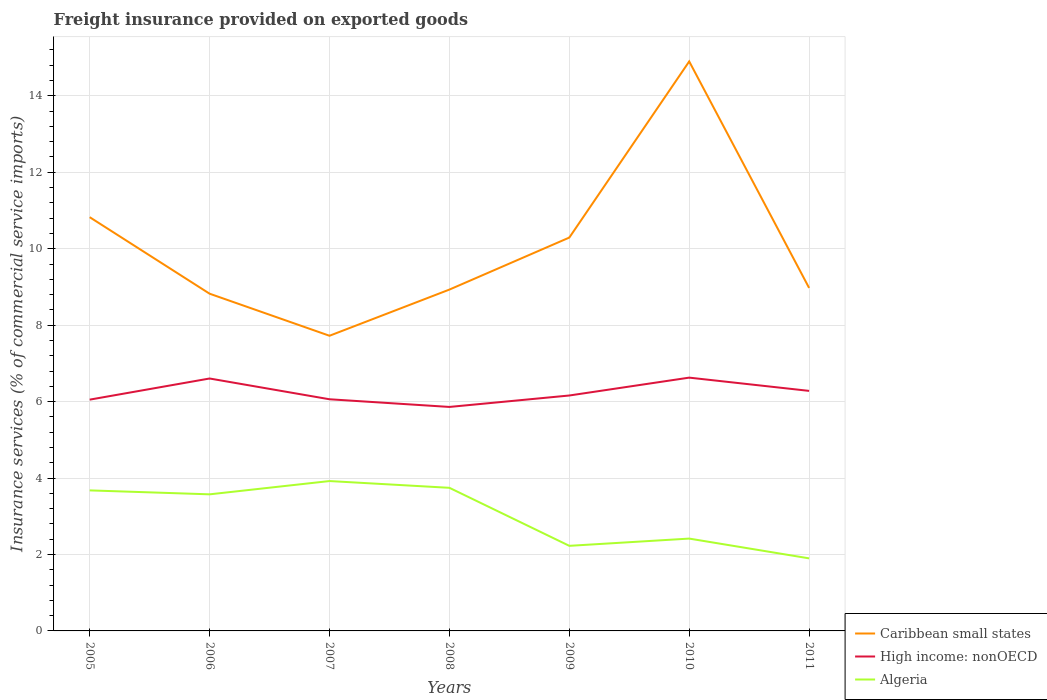How many different coloured lines are there?
Your answer should be very brief. 3. Is the number of lines equal to the number of legend labels?
Your response must be concise. Yes. Across all years, what is the maximum freight insurance provided on exported goods in Caribbean small states?
Provide a short and direct response. 7.72. What is the total freight insurance provided on exported goods in Caribbean small states in the graph?
Your answer should be very brief. -1.47. What is the difference between the highest and the second highest freight insurance provided on exported goods in High income: nonOECD?
Offer a very short reply. 0.77. How many lines are there?
Provide a succinct answer. 3. How many years are there in the graph?
Offer a terse response. 7. Are the values on the major ticks of Y-axis written in scientific E-notation?
Offer a very short reply. No. Does the graph contain grids?
Keep it short and to the point. Yes. How many legend labels are there?
Your answer should be compact. 3. What is the title of the graph?
Provide a short and direct response. Freight insurance provided on exported goods. What is the label or title of the X-axis?
Keep it short and to the point. Years. What is the label or title of the Y-axis?
Give a very brief answer. Insurance services (% of commercial service imports). What is the Insurance services (% of commercial service imports) in Caribbean small states in 2005?
Your answer should be compact. 10.83. What is the Insurance services (% of commercial service imports) of High income: nonOECD in 2005?
Keep it short and to the point. 6.05. What is the Insurance services (% of commercial service imports) in Algeria in 2005?
Keep it short and to the point. 3.68. What is the Insurance services (% of commercial service imports) of Caribbean small states in 2006?
Keep it short and to the point. 8.82. What is the Insurance services (% of commercial service imports) of High income: nonOECD in 2006?
Provide a succinct answer. 6.6. What is the Insurance services (% of commercial service imports) of Algeria in 2006?
Make the answer very short. 3.57. What is the Insurance services (% of commercial service imports) in Caribbean small states in 2007?
Your answer should be very brief. 7.72. What is the Insurance services (% of commercial service imports) of High income: nonOECD in 2007?
Ensure brevity in your answer.  6.06. What is the Insurance services (% of commercial service imports) of Algeria in 2007?
Keep it short and to the point. 3.92. What is the Insurance services (% of commercial service imports) of Caribbean small states in 2008?
Keep it short and to the point. 8.93. What is the Insurance services (% of commercial service imports) of High income: nonOECD in 2008?
Give a very brief answer. 5.86. What is the Insurance services (% of commercial service imports) of Algeria in 2008?
Give a very brief answer. 3.74. What is the Insurance services (% of commercial service imports) in Caribbean small states in 2009?
Provide a succinct answer. 10.29. What is the Insurance services (% of commercial service imports) of High income: nonOECD in 2009?
Provide a succinct answer. 6.16. What is the Insurance services (% of commercial service imports) of Algeria in 2009?
Make the answer very short. 2.23. What is the Insurance services (% of commercial service imports) in Caribbean small states in 2010?
Provide a succinct answer. 14.9. What is the Insurance services (% of commercial service imports) of High income: nonOECD in 2010?
Provide a succinct answer. 6.63. What is the Insurance services (% of commercial service imports) in Algeria in 2010?
Provide a succinct answer. 2.42. What is the Insurance services (% of commercial service imports) in Caribbean small states in 2011?
Your response must be concise. 8.97. What is the Insurance services (% of commercial service imports) in High income: nonOECD in 2011?
Provide a succinct answer. 6.28. What is the Insurance services (% of commercial service imports) of Algeria in 2011?
Offer a terse response. 1.9. Across all years, what is the maximum Insurance services (% of commercial service imports) of Caribbean small states?
Make the answer very short. 14.9. Across all years, what is the maximum Insurance services (% of commercial service imports) in High income: nonOECD?
Offer a terse response. 6.63. Across all years, what is the maximum Insurance services (% of commercial service imports) of Algeria?
Your answer should be very brief. 3.92. Across all years, what is the minimum Insurance services (% of commercial service imports) in Caribbean small states?
Ensure brevity in your answer.  7.72. Across all years, what is the minimum Insurance services (% of commercial service imports) of High income: nonOECD?
Offer a very short reply. 5.86. Across all years, what is the minimum Insurance services (% of commercial service imports) in Algeria?
Give a very brief answer. 1.9. What is the total Insurance services (% of commercial service imports) in Caribbean small states in the graph?
Provide a succinct answer. 70.47. What is the total Insurance services (% of commercial service imports) in High income: nonOECD in the graph?
Make the answer very short. 43.64. What is the total Insurance services (% of commercial service imports) of Algeria in the graph?
Offer a very short reply. 21.46. What is the difference between the Insurance services (% of commercial service imports) of Caribbean small states in 2005 and that in 2006?
Provide a succinct answer. 2. What is the difference between the Insurance services (% of commercial service imports) in High income: nonOECD in 2005 and that in 2006?
Offer a very short reply. -0.55. What is the difference between the Insurance services (% of commercial service imports) of Algeria in 2005 and that in 2006?
Offer a terse response. 0.1. What is the difference between the Insurance services (% of commercial service imports) in Caribbean small states in 2005 and that in 2007?
Keep it short and to the point. 3.1. What is the difference between the Insurance services (% of commercial service imports) in High income: nonOECD in 2005 and that in 2007?
Your response must be concise. -0.01. What is the difference between the Insurance services (% of commercial service imports) in Algeria in 2005 and that in 2007?
Provide a short and direct response. -0.24. What is the difference between the Insurance services (% of commercial service imports) of Caribbean small states in 2005 and that in 2008?
Ensure brevity in your answer.  1.89. What is the difference between the Insurance services (% of commercial service imports) of High income: nonOECD in 2005 and that in 2008?
Offer a very short reply. 0.19. What is the difference between the Insurance services (% of commercial service imports) of Algeria in 2005 and that in 2008?
Your response must be concise. -0.07. What is the difference between the Insurance services (% of commercial service imports) in Caribbean small states in 2005 and that in 2009?
Your answer should be very brief. 0.53. What is the difference between the Insurance services (% of commercial service imports) of High income: nonOECD in 2005 and that in 2009?
Your answer should be compact. -0.11. What is the difference between the Insurance services (% of commercial service imports) in Algeria in 2005 and that in 2009?
Offer a very short reply. 1.45. What is the difference between the Insurance services (% of commercial service imports) of Caribbean small states in 2005 and that in 2010?
Provide a short and direct response. -4.08. What is the difference between the Insurance services (% of commercial service imports) in High income: nonOECD in 2005 and that in 2010?
Provide a succinct answer. -0.58. What is the difference between the Insurance services (% of commercial service imports) in Algeria in 2005 and that in 2010?
Keep it short and to the point. 1.26. What is the difference between the Insurance services (% of commercial service imports) of Caribbean small states in 2005 and that in 2011?
Your answer should be very brief. 1.85. What is the difference between the Insurance services (% of commercial service imports) of High income: nonOECD in 2005 and that in 2011?
Your response must be concise. -0.23. What is the difference between the Insurance services (% of commercial service imports) of Algeria in 2005 and that in 2011?
Your answer should be compact. 1.78. What is the difference between the Insurance services (% of commercial service imports) in Caribbean small states in 2006 and that in 2007?
Ensure brevity in your answer.  1.1. What is the difference between the Insurance services (% of commercial service imports) of High income: nonOECD in 2006 and that in 2007?
Provide a succinct answer. 0.54. What is the difference between the Insurance services (% of commercial service imports) in Algeria in 2006 and that in 2007?
Provide a short and direct response. -0.35. What is the difference between the Insurance services (% of commercial service imports) in Caribbean small states in 2006 and that in 2008?
Your answer should be compact. -0.11. What is the difference between the Insurance services (% of commercial service imports) in High income: nonOECD in 2006 and that in 2008?
Keep it short and to the point. 0.74. What is the difference between the Insurance services (% of commercial service imports) of Algeria in 2006 and that in 2008?
Give a very brief answer. -0.17. What is the difference between the Insurance services (% of commercial service imports) in Caribbean small states in 2006 and that in 2009?
Offer a terse response. -1.47. What is the difference between the Insurance services (% of commercial service imports) of High income: nonOECD in 2006 and that in 2009?
Make the answer very short. 0.45. What is the difference between the Insurance services (% of commercial service imports) in Algeria in 2006 and that in 2009?
Provide a short and direct response. 1.35. What is the difference between the Insurance services (% of commercial service imports) in Caribbean small states in 2006 and that in 2010?
Offer a terse response. -6.08. What is the difference between the Insurance services (% of commercial service imports) of High income: nonOECD in 2006 and that in 2010?
Offer a very short reply. -0.02. What is the difference between the Insurance services (% of commercial service imports) of Algeria in 2006 and that in 2010?
Your answer should be very brief. 1.16. What is the difference between the Insurance services (% of commercial service imports) in Caribbean small states in 2006 and that in 2011?
Offer a terse response. -0.15. What is the difference between the Insurance services (% of commercial service imports) of High income: nonOECD in 2006 and that in 2011?
Your answer should be very brief. 0.32. What is the difference between the Insurance services (% of commercial service imports) of Algeria in 2006 and that in 2011?
Make the answer very short. 1.68. What is the difference between the Insurance services (% of commercial service imports) of Caribbean small states in 2007 and that in 2008?
Provide a short and direct response. -1.21. What is the difference between the Insurance services (% of commercial service imports) of High income: nonOECD in 2007 and that in 2008?
Give a very brief answer. 0.2. What is the difference between the Insurance services (% of commercial service imports) in Algeria in 2007 and that in 2008?
Offer a very short reply. 0.18. What is the difference between the Insurance services (% of commercial service imports) in Caribbean small states in 2007 and that in 2009?
Your response must be concise. -2.57. What is the difference between the Insurance services (% of commercial service imports) of High income: nonOECD in 2007 and that in 2009?
Offer a very short reply. -0.1. What is the difference between the Insurance services (% of commercial service imports) of Algeria in 2007 and that in 2009?
Provide a succinct answer. 1.69. What is the difference between the Insurance services (% of commercial service imports) in Caribbean small states in 2007 and that in 2010?
Provide a succinct answer. -7.18. What is the difference between the Insurance services (% of commercial service imports) in High income: nonOECD in 2007 and that in 2010?
Provide a short and direct response. -0.57. What is the difference between the Insurance services (% of commercial service imports) of Algeria in 2007 and that in 2010?
Ensure brevity in your answer.  1.51. What is the difference between the Insurance services (% of commercial service imports) in Caribbean small states in 2007 and that in 2011?
Your answer should be very brief. -1.25. What is the difference between the Insurance services (% of commercial service imports) in High income: nonOECD in 2007 and that in 2011?
Offer a terse response. -0.22. What is the difference between the Insurance services (% of commercial service imports) of Algeria in 2007 and that in 2011?
Keep it short and to the point. 2.02. What is the difference between the Insurance services (% of commercial service imports) of Caribbean small states in 2008 and that in 2009?
Give a very brief answer. -1.36. What is the difference between the Insurance services (% of commercial service imports) in High income: nonOECD in 2008 and that in 2009?
Your answer should be compact. -0.3. What is the difference between the Insurance services (% of commercial service imports) in Algeria in 2008 and that in 2009?
Provide a succinct answer. 1.52. What is the difference between the Insurance services (% of commercial service imports) of Caribbean small states in 2008 and that in 2010?
Give a very brief answer. -5.97. What is the difference between the Insurance services (% of commercial service imports) of High income: nonOECD in 2008 and that in 2010?
Offer a very short reply. -0.77. What is the difference between the Insurance services (% of commercial service imports) in Algeria in 2008 and that in 2010?
Offer a very short reply. 1.33. What is the difference between the Insurance services (% of commercial service imports) of Caribbean small states in 2008 and that in 2011?
Offer a very short reply. -0.04. What is the difference between the Insurance services (% of commercial service imports) of High income: nonOECD in 2008 and that in 2011?
Your answer should be very brief. -0.42. What is the difference between the Insurance services (% of commercial service imports) in Algeria in 2008 and that in 2011?
Your answer should be very brief. 1.85. What is the difference between the Insurance services (% of commercial service imports) of Caribbean small states in 2009 and that in 2010?
Keep it short and to the point. -4.61. What is the difference between the Insurance services (% of commercial service imports) in High income: nonOECD in 2009 and that in 2010?
Keep it short and to the point. -0.47. What is the difference between the Insurance services (% of commercial service imports) of Algeria in 2009 and that in 2010?
Make the answer very short. -0.19. What is the difference between the Insurance services (% of commercial service imports) of Caribbean small states in 2009 and that in 2011?
Your answer should be very brief. 1.32. What is the difference between the Insurance services (% of commercial service imports) in High income: nonOECD in 2009 and that in 2011?
Offer a terse response. -0.12. What is the difference between the Insurance services (% of commercial service imports) of Algeria in 2009 and that in 2011?
Ensure brevity in your answer.  0.33. What is the difference between the Insurance services (% of commercial service imports) of Caribbean small states in 2010 and that in 2011?
Give a very brief answer. 5.93. What is the difference between the Insurance services (% of commercial service imports) of High income: nonOECD in 2010 and that in 2011?
Provide a succinct answer. 0.35. What is the difference between the Insurance services (% of commercial service imports) of Algeria in 2010 and that in 2011?
Keep it short and to the point. 0.52. What is the difference between the Insurance services (% of commercial service imports) in Caribbean small states in 2005 and the Insurance services (% of commercial service imports) in High income: nonOECD in 2006?
Make the answer very short. 4.22. What is the difference between the Insurance services (% of commercial service imports) in Caribbean small states in 2005 and the Insurance services (% of commercial service imports) in Algeria in 2006?
Offer a terse response. 7.25. What is the difference between the Insurance services (% of commercial service imports) of High income: nonOECD in 2005 and the Insurance services (% of commercial service imports) of Algeria in 2006?
Provide a succinct answer. 2.48. What is the difference between the Insurance services (% of commercial service imports) of Caribbean small states in 2005 and the Insurance services (% of commercial service imports) of High income: nonOECD in 2007?
Provide a short and direct response. 4.76. What is the difference between the Insurance services (% of commercial service imports) in Caribbean small states in 2005 and the Insurance services (% of commercial service imports) in Algeria in 2007?
Keep it short and to the point. 6.9. What is the difference between the Insurance services (% of commercial service imports) in High income: nonOECD in 2005 and the Insurance services (% of commercial service imports) in Algeria in 2007?
Your answer should be compact. 2.13. What is the difference between the Insurance services (% of commercial service imports) of Caribbean small states in 2005 and the Insurance services (% of commercial service imports) of High income: nonOECD in 2008?
Ensure brevity in your answer.  4.97. What is the difference between the Insurance services (% of commercial service imports) of Caribbean small states in 2005 and the Insurance services (% of commercial service imports) of Algeria in 2008?
Provide a succinct answer. 7.08. What is the difference between the Insurance services (% of commercial service imports) of High income: nonOECD in 2005 and the Insurance services (% of commercial service imports) of Algeria in 2008?
Offer a very short reply. 2.31. What is the difference between the Insurance services (% of commercial service imports) of Caribbean small states in 2005 and the Insurance services (% of commercial service imports) of High income: nonOECD in 2009?
Ensure brevity in your answer.  4.67. What is the difference between the Insurance services (% of commercial service imports) in Caribbean small states in 2005 and the Insurance services (% of commercial service imports) in Algeria in 2009?
Keep it short and to the point. 8.6. What is the difference between the Insurance services (% of commercial service imports) in High income: nonOECD in 2005 and the Insurance services (% of commercial service imports) in Algeria in 2009?
Your response must be concise. 3.83. What is the difference between the Insurance services (% of commercial service imports) in Caribbean small states in 2005 and the Insurance services (% of commercial service imports) in High income: nonOECD in 2010?
Keep it short and to the point. 4.2. What is the difference between the Insurance services (% of commercial service imports) of Caribbean small states in 2005 and the Insurance services (% of commercial service imports) of Algeria in 2010?
Your answer should be compact. 8.41. What is the difference between the Insurance services (% of commercial service imports) of High income: nonOECD in 2005 and the Insurance services (% of commercial service imports) of Algeria in 2010?
Offer a terse response. 3.64. What is the difference between the Insurance services (% of commercial service imports) in Caribbean small states in 2005 and the Insurance services (% of commercial service imports) in High income: nonOECD in 2011?
Provide a short and direct response. 4.54. What is the difference between the Insurance services (% of commercial service imports) of Caribbean small states in 2005 and the Insurance services (% of commercial service imports) of Algeria in 2011?
Keep it short and to the point. 8.93. What is the difference between the Insurance services (% of commercial service imports) in High income: nonOECD in 2005 and the Insurance services (% of commercial service imports) in Algeria in 2011?
Offer a terse response. 4.15. What is the difference between the Insurance services (% of commercial service imports) of Caribbean small states in 2006 and the Insurance services (% of commercial service imports) of High income: nonOECD in 2007?
Provide a short and direct response. 2.76. What is the difference between the Insurance services (% of commercial service imports) in Caribbean small states in 2006 and the Insurance services (% of commercial service imports) in Algeria in 2007?
Keep it short and to the point. 4.9. What is the difference between the Insurance services (% of commercial service imports) in High income: nonOECD in 2006 and the Insurance services (% of commercial service imports) in Algeria in 2007?
Make the answer very short. 2.68. What is the difference between the Insurance services (% of commercial service imports) of Caribbean small states in 2006 and the Insurance services (% of commercial service imports) of High income: nonOECD in 2008?
Your response must be concise. 2.96. What is the difference between the Insurance services (% of commercial service imports) in Caribbean small states in 2006 and the Insurance services (% of commercial service imports) in Algeria in 2008?
Offer a terse response. 5.08. What is the difference between the Insurance services (% of commercial service imports) in High income: nonOECD in 2006 and the Insurance services (% of commercial service imports) in Algeria in 2008?
Your answer should be compact. 2.86. What is the difference between the Insurance services (% of commercial service imports) in Caribbean small states in 2006 and the Insurance services (% of commercial service imports) in High income: nonOECD in 2009?
Your response must be concise. 2.66. What is the difference between the Insurance services (% of commercial service imports) in Caribbean small states in 2006 and the Insurance services (% of commercial service imports) in Algeria in 2009?
Offer a very short reply. 6.6. What is the difference between the Insurance services (% of commercial service imports) of High income: nonOECD in 2006 and the Insurance services (% of commercial service imports) of Algeria in 2009?
Give a very brief answer. 4.38. What is the difference between the Insurance services (% of commercial service imports) of Caribbean small states in 2006 and the Insurance services (% of commercial service imports) of High income: nonOECD in 2010?
Give a very brief answer. 2.2. What is the difference between the Insurance services (% of commercial service imports) in Caribbean small states in 2006 and the Insurance services (% of commercial service imports) in Algeria in 2010?
Ensure brevity in your answer.  6.41. What is the difference between the Insurance services (% of commercial service imports) in High income: nonOECD in 2006 and the Insurance services (% of commercial service imports) in Algeria in 2010?
Offer a terse response. 4.19. What is the difference between the Insurance services (% of commercial service imports) of Caribbean small states in 2006 and the Insurance services (% of commercial service imports) of High income: nonOECD in 2011?
Give a very brief answer. 2.54. What is the difference between the Insurance services (% of commercial service imports) of Caribbean small states in 2006 and the Insurance services (% of commercial service imports) of Algeria in 2011?
Keep it short and to the point. 6.92. What is the difference between the Insurance services (% of commercial service imports) in High income: nonOECD in 2006 and the Insurance services (% of commercial service imports) in Algeria in 2011?
Provide a succinct answer. 4.71. What is the difference between the Insurance services (% of commercial service imports) of Caribbean small states in 2007 and the Insurance services (% of commercial service imports) of High income: nonOECD in 2008?
Your response must be concise. 1.86. What is the difference between the Insurance services (% of commercial service imports) of Caribbean small states in 2007 and the Insurance services (% of commercial service imports) of Algeria in 2008?
Provide a succinct answer. 3.98. What is the difference between the Insurance services (% of commercial service imports) in High income: nonOECD in 2007 and the Insurance services (% of commercial service imports) in Algeria in 2008?
Ensure brevity in your answer.  2.32. What is the difference between the Insurance services (% of commercial service imports) of Caribbean small states in 2007 and the Insurance services (% of commercial service imports) of High income: nonOECD in 2009?
Give a very brief answer. 1.56. What is the difference between the Insurance services (% of commercial service imports) of Caribbean small states in 2007 and the Insurance services (% of commercial service imports) of Algeria in 2009?
Offer a terse response. 5.5. What is the difference between the Insurance services (% of commercial service imports) in High income: nonOECD in 2007 and the Insurance services (% of commercial service imports) in Algeria in 2009?
Your answer should be compact. 3.83. What is the difference between the Insurance services (% of commercial service imports) of Caribbean small states in 2007 and the Insurance services (% of commercial service imports) of High income: nonOECD in 2010?
Give a very brief answer. 1.1. What is the difference between the Insurance services (% of commercial service imports) in Caribbean small states in 2007 and the Insurance services (% of commercial service imports) in Algeria in 2010?
Your answer should be very brief. 5.31. What is the difference between the Insurance services (% of commercial service imports) in High income: nonOECD in 2007 and the Insurance services (% of commercial service imports) in Algeria in 2010?
Keep it short and to the point. 3.65. What is the difference between the Insurance services (% of commercial service imports) in Caribbean small states in 2007 and the Insurance services (% of commercial service imports) in High income: nonOECD in 2011?
Your answer should be very brief. 1.44. What is the difference between the Insurance services (% of commercial service imports) of Caribbean small states in 2007 and the Insurance services (% of commercial service imports) of Algeria in 2011?
Keep it short and to the point. 5.82. What is the difference between the Insurance services (% of commercial service imports) in High income: nonOECD in 2007 and the Insurance services (% of commercial service imports) in Algeria in 2011?
Your response must be concise. 4.16. What is the difference between the Insurance services (% of commercial service imports) in Caribbean small states in 2008 and the Insurance services (% of commercial service imports) in High income: nonOECD in 2009?
Offer a very short reply. 2.77. What is the difference between the Insurance services (% of commercial service imports) of Caribbean small states in 2008 and the Insurance services (% of commercial service imports) of Algeria in 2009?
Your answer should be compact. 6.7. What is the difference between the Insurance services (% of commercial service imports) in High income: nonOECD in 2008 and the Insurance services (% of commercial service imports) in Algeria in 2009?
Offer a terse response. 3.63. What is the difference between the Insurance services (% of commercial service imports) of Caribbean small states in 2008 and the Insurance services (% of commercial service imports) of High income: nonOECD in 2010?
Make the answer very short. 2.3. What is the difference between the Insurance services (% of commercial service imports) of Caribbean small states in 2008 and the Insurance services (% of commercial service imports) of Algeria in 2010?
Ensure brevity in your answer.  6.51. What is the difference between the Insurance services (% of commercial service imports) of High income: nonOECD in 2008 and the Insurance services (% of commercial service imports) of Algeria in 2010?
Your answer should be compact. 3.44. What is the difference between the Insurance services (% of commercial service imports) of Caribbean small states in 2008 and the Insurance services (% of commercial service imports) of High income: nonOECD in 2011?
Your answer should be very brief. 2.65. What is the difference between the Insurance services (% of commercial service imports) in Caribbean small states in 2008 and the Insurance services (% of commercial service imports) in Algeria in 2011?
Your response must be concise. 7.03. What is the difference between the Insurance services (% of commercial service imports) of High income: nonOECD in 2008 and the Insurance services (% of commercial service imports) of Algeria in 2011?
Your answer should be very brief. 3.96. What is the difference between the Insurance services (% of commercial service imports) in Caribbean small states in 2009 and the Insurance services (% of commercial service imports) in High income: nonOECD in 2010?
Provide a short and direct response. 3.66. What is the difference between the Insurance services (% of commercial service imports) in Caribbean small states in 2009 and the Insurance services (% of commercial service imports) in Algeria in 2010?
Offer a terse response. 7.88. What is the difference between the Insurance services (% of commercial service imports) in High income: nonOECD in 2009 and the Insurance services (% of commercial service imports) in Algeria in 2010?
Offer a terse response. 3.74. What is the difference between the Insurance services (% of commercial service imports) of Caribbean small states in 2009 and the Insurance services (% of commercial service imports) of High income: nonOECD in 2011?
Give a very brief answer. 4.01. What is the difference between the Insurance services (% of commercial service imports) in Caribbean small states in 2009 and the Insurance services (% of commercial service imports) in Algeria in 2011?
Offer a terse response. 8.39. What is the difference between the Insurance services (% of commercial service imports) of High income: nonOECD in 2009 and the Insurance services (% of commercial service imports) of Algeria in 2011?
Make the answer very short. 4.26. What is the difference between the Insurance services (% of commercial service imports) of Caribbean small states in 2010 and the Insurance services (% of commercial service imports) of High income: nonOECD in 2011?
Provide a succinct answer. 8.62. What is the difference between the Insurance services (% of commercial service imports) in Caribbean small states in 2010 and the Insurance services (% of commercial service imports) in Algeria in 2011?
Provide a short and direct response. 13. What is the difference between the Insurance services (% of commercial service imports) in High income: nonOECD in 2010 and the Insurance services (% of commercial service imports) in Algeria in 2011?
Offer a very short reply. 4.73. What is the average Insurance services (% of commercial service imports) of Caribbean small states per year?
Make the answer very short. 10.07. What is the average Insurance services (% of commercial service imports) of High income: nonOECD per year?
Your answer should be compact. 6.24. What is the average Insurance services (% of commercial service imports) in Algeria per year?
Offer a terse response. 3.07. In the year 2005, what is the difference between the Insurance services (% of commercial service imports) of Caribbean small states and Insurance services (% of commercial service imports) of High income: nonOECD?
Provide a succinct answer. 4.77. In the year 2005, what is the difference between the Insurance services (% of commercial service imports) in Caribbean small states and Insurance services (% of commercial service imports) in Algeria?
Make the answer very short. 7.15. In the year 2005, what is the difference between the Insurance services (% of commercial service imports) of High income: nonOECD and Insurance services (% of commercial service imports) of Algeria?
Make the answer very short. 2.37. In the year 2006, what is the difference between the Insurance services (% of commercial service imports) of Caribbean small states and Insurance services (% of commercial service imports) of High income: nonOECD?
Offer a terse response. 2.22. In the year 2006, what is the difference between the Insurance services (% of commercial service imports) of Caribbean small states and Insurance services (% of commercial service imports) of Algeria?
Your answer should be very brief. 5.25. In the year 2006, what is the difference between the Insurance services (% of commercial service imports) in High income: nonOECD and Insurance services (% of commercial service imports) in Algeria?
Your response must be concise. 3.03. In the year 2007, what is the difference between the Insurance services (% of commercial service imports) of Caribbean small states and Insurance services (% of commercial service imports) of High income: nonOECD?
Offer a very short reply. 1.66. In the year 2007, what is the difference between the Insurance services (% of commercial service imports) in Caribbean small states and Insurance services (% of commercial service imports) in Algeria?
Provide a succinct answer. 3.8. In the year 2007, what is the difference between the Insurance services (% of commercial service imports) in High income: nonOECD and Insurance services (% of commercial service imports) in Algeria?
Make the answer very short. 2.14. In the year 2008, what is the difference between the Insurance services (% of commercial service imports) of Caribbean small states and Insurance services (% of commercial service imports) of High income: nonOECD?
Your response must be concise. 3.07. In the year 2008, what is the difference between the Insurance services (% of commercial service imports) in Caribbean small states and Insurance services (% of commercial service imports) in Algeria?
Keep it short and to the point. 5.19. In the year 2008, what is the difference between the Insurance services (% of commercial service imports) in High income: nonOECD and Insurance services (% of commercial service imports) in Algeria?
Your answer should be very brief. 2.12. In the year 2009, what is the difference between the Insurance services (% of commercial service imports) of Caribbean small states and Insurance services (% of commercial service imports) of High income: nonOECD?
Offer a very short reply. 4.13. In the year 2009, what is the difference between the Insurance services (% of commercial service imports) of Caribbean small states and Insurance services (% of commercial service imports) of Algeria?
Your response must be concise. 8.07. In the year 2009, what is the difference between the Insurance services (% of commercial service imports) in High income: nonOECD and Insurance services (% of commercial service imports) in Algeria?
Your response must be concise. 3.93. In the year 2010, what is the difference between the Insurance services (% of commercial service imports) in Caribbean small states and Insurance services (% of commercial service imports) in High income: nonOECD?
Your response must be concise. 8.27. In the year 2010, what is the difference between the Insurance services (% of commercial service imports) of Caribbean small states and Insurance services (% of commercial service imports) of Algeria?
Your response must be concise. 12.48. In the year 2010, what is the difference between the Insurance services (% of commercial service imports) of High income: nonOECD and Insurance services (% of commercial service imports) of Algeria?
Offer a terse response. 4.21. In the year 2011, what is the difference between the Insurance services (% of commercial service imports) of Caribbean small states and Insurance services (% of commercial service imports) of High income: nonOECD?
Make the answer very short. 2.69. In the year 2011, what is the difference between the Insurance services (% of commercial service imports) in Caribbean small states and Insurance services (% of commercial service imports) in Algeria?
Offer a terse response. 7.08. In the year 2011, what is the difference between the Insurance services (% of commercial service imports) of High income: nonOECD and Insurance services (% of commercial service imports) of Algeria?
Make the answer very short. 4.38. What is the ratio of the Insurance services (% of commercial service imports) of Caribbean small states in 2005 to that in 2006?
Make the answer very short. 1.23. What is the ratio of the Insurance services (% of commercial service imports) in High income: nonOECD in 2005 to that in 2006?
Offer a very short reply. 0.92. What is the ratio of the Insurance services (% of commercial service imports) of Algeria in 2005 to that in 2006?
Provide a succinct answer. 1.03. What is the ratio of the Insurance services (% of commercial service imports) in Caribbean small states in 2005 to that in 2007?
Provide a succinct answer. 1.4. What is the ratio of the Insurance services (% of commercial service imports) of Algeria in 2005 to that in 2007?
Your answer should be compact. 0.94. What is the ratio of the Insurance services (% of commercial service imports) of Caribbean small states in 2005 to that in 2008?
Your answer should be very brief. 1.21. What is the ratio of the Insurance services (% of commercial service imports) of High income: nonOECD in 2005 to that in 2008?
Your answer should be very brief. 1.03. What is the ratio of the Insurance services (% of commercial service imports) of Algeria in 2005 to that in 2008?
Make the answer very short. 0.98. What is the ratio of the Insurance services (% of commercial service imports) of Caribbean small states in 2005 to that in 2009?
Provide a short and direct response. 1.05. What is the ratio of the Insurance services (% of commercial service imports) in High income: nonOECD in 2005 to that in 2009?
Provide a short and direct response. 0.98. What is the ratio of the Insurance services (% of commercial service imports) of Algeria in 2005 to that in 2009?
Ensure brevity in your answer.  1.65. What is the ratio of the Insurance services (% of commercial service imports) of Caribbean small states in 2005 to that in 2010?
Ensure brevity in your answer.  0.73. What is the ratio of the Insurance services (% of commercial service imports) in High income: nonOECD in 2005 to that in 2010?
Provide a succinct answer. 0.91. What is the ratio of the Insurance services (% of commercial service imports) of Algeria in 2005 to that in 2010?
Provide a short and direct response. 1.52. What is the ratio of the Insurance services (% of commercial service imports) of Caribbean small states in 2005 to that in 2011?
Give a very brief answer. 1.21. What is the ratio of the Insurance services (% of commercial service imports) in High income: nonOECD in 2005 to that in 2011?
Make the answer very short. 0.96. What is the ratio of the Insurance services (% of commercial service imports) of Algeria in 2005 to that in 2011?
Keep it short and to the point. 1.94. What is the ratio of the Insurance services (% of commercial service imports) in Caribbean small states in 2006 to that in 2007?
Offer a terse response. 1.14. What is the ratio of the Insurance services (% of commercial service imports) in High income: nonOECD in 2006 to that in 2007?
Offer a very short reply. 1.09. What is the ratio of the Insurance services (% of commercial service imports) in Algeria in 2006 to that in 2007?
Make the answer very short. 0.91. What is the ratio of the Insurance services (% of commercial service imports) in Caribbean small states in 2006 to that in 2008?
Make the answer very short. 0.99. What is the ratio of the Insurance services (% of commercial service imports) of High income: nonOECD in 2006 to that in 2008?
Keep it short and to the point. 1.13. What is the ratio of the Insurance services (% of commercial service imports) in Algeria in 2006 to that in 2008?
Offer a very short reply. 0.95. What is the ratio of the Insurance services (% of commercial service imports) of Caribbean small states in 2006 to that in 2009?
Your response must be concise. 0.86. What is the ratio of the Insurance services (% of commercial service imports) of High income: nonOECD in 2006 to that in 2009?
Offer a terse response. 1.07. What is the ratio of the Insurance services (% of commercial service imports) of Algeria in 2006 to that in 2009?
Give a very brief answer. 1.61. What is the ratio of the Insurance services (% of commercial service imports) in Caribbean small states in 2006 to that in 2010?
Your answer should be compact. 0.59. What is the ratio of the Insurance services (% of commercial service imports) in High income: nonOECD in 2006 to that in 2010?
Provide a short and direct response. 1. What is the ratio of the Insurance services (% of commercial service imports) of Algeria in 2006 to that in 2010?
Provide a succinct answer. 1.48. What is the ratio of the Insurance services (% of commercial service imports) in Caribbean small states in 2006 to that in 2011?
Keep it short and to the point. 0.98. What is the ratio of the Insurance services (% of commercial service imports) of High income: nonOECD in 2006 to that in 2011?
Offer a very short reply. 1.05. What is the ratio of the Insurance services (% of commercial service imports) of Algeria in 2006 to that in 2011?
Your answer should be compact. 1.88. What is the ratio of the Insurance services (% of commercial service imports) in Caribbean small states in 2007 to that in 2008?
Ensure brevity in your answer.  0.86. What is the ratio of the Insurance services (% of commercial service imports) of High income: nonOECD in 2007 to that in 2008?
Give a very brief answer. 1.03. What is the ratio of the Insurance services (% of commercial service imports) in Algeria in 2007 to that in 2008?
Offer a very short reply. 1.05. What is the ratio of the Insurance services (% of commercial service imports) in Caribbean small states in 2007 to that in 2009?
Ensure brevity in your answer.  0.75. What is the ratio of the Insurance services (% of commercial service imports) in High income: nonOECD in 2007 to that in 2009?
Your response must be concise. 0.98. What is the ratio of the Insurance services (% of commercial service imports) of Algeria in 2007 to that in 2009?
Ensure brevity in your answer.  1.76. What is the ratio of the Insurance services (% of commercial service imports) in Caribbean small states in 2007 to that in 2010?
Give a very brief answer. 0.52. What is the ratio of the Insurance services (% of commercial service imports) in High income: nonOECD in 2007 to that in 2010?
Your answer should be compact. 0.91. What is the ratio of the Insurance services (% of commercial service imports) in Algeria in 2007 to that in 2010?
Your answer should be compact. 1.62. What is the ratio of the Insurance services (% of commercial service imports) in Caribbean small states in 2007 to that in 2011?
Your answer should be very brief. 0.86. What is the ratio of the Insurance services (% of commercial service imports) in High income: nonOECD in 2007 to that in 2011?
Give a very brief answer. 0.96. What is the ratio of the Insurance services (% of commercial service imports) in Algeria in 2007 to that in 2011?
Make the answer very short. 2.07. What is the ratio of the Insurance services (% of commercial service imports) in Caribbean small states in 2008 to that in 2009?
Your answer should be very brief. 0.87. What is the ratio of the Insurance services (% of commercial service imports) of High income: nonOECD in 2008 to that in 2009?
Make the answer very short. 0.95. What is the ratio of the Insurance services (% of commercial service imports) in Algeria in 2008 to that in 2009?
Your response must be concise. 1.68. What is the ratio of the Insurance services (% of commercial service imports) of Caribbean small states in 2008 to that in 2010?
Give a very brief answer. 0.6. What is the ratio of the Insurance services (% of commercial service imports) of High income: nonOECD in 2008 to that in 2010?
Offer a very short reply. 0.88. What is the ratio of the Insurance services (% of commercial service imports) in Algeria in 2008 to that in 2010?
Provide a succinct answer. 1.55. What is the ratio of the Insurance services (% of commercial service imports) in High income: nonOECD in 2008 to that in 2011?
Provide a succinct answer. 0.93. What is the ratio of the Insurance services (% of commercial service imports) of Algeria in 2008 to that in 2011?
Your answer should be very brief. 1.97. What is the ratio of the Insurance services (% of commercial service imports) of Caribbean small states in 2009 to that in 2010?
Your response must be concise. 0.69. What is the ratio of the Insurance services (% of commercial service imports) in High income: nonOECD in 2009 to that in 2010?
Your answer should be compact. 0.93. What is the ratio of the Insurance services (% of commercial service imports) of Algeria in 2009 to that in 2010?
Make the answer very short. 0.92. What is the ratio of the Insurance services (% of commercial service imports) of Caribbean small states in 2009 to that in 2011?
Offer a terse response. 1.15. What is the ratio of the Insurance services (% of commercial service imports) in High income: nonOECD in 2009 to that in 2011?
Provide a short and direct response. 0.98. What is the ratio of the Insurance services (% of commercial service imports) of Algeria in 2009 to that in 2011?
Ensure brevity in your answer.  1.17. What is the ratio of the Insurance services (% of commercial service imports) of Caribbean small states in 2010 to that in 2011?
Ensure brevity in your answer.  1.66. What is the ratio of the Insurance services (% of commercial service imports) of High income: nonOECD in 2010 to that in 2011?
Ensure brevity in your answer.  1.06. What is the ratio of the Insurance services (% of commercial service imports) in Algeria in 2010 to that in 2011?
Offer a very short reply. 1.27. What is the difference between the highest and the second highest Insurance services (% of commercial service imports) of Caribbean small states?
Your answer should be compact. 4.08. What is the difference between the highest and the second highest Insurance services (% of commercial service imports) in High income: nonOECD?
Provide a short and direct response. 0.02. What is the difference between the highest and the second highest Insurance services (% of commercial service imports) of Algeria?
Your answer should be compact. 0.18. What is the difference between the highest and the lowest Insurance services (% of commercial service imports) in Caribbean small states?
Provide a short and direct response. 7.18. What is the difference between the highest and the lowest Insurance services (% of commercial service imports) in High income: nonOECD?
Offer a very short reply. 0.77. What is the difference between the highest and the lowest Insurance services (% of commercial service imports) in Algeria?
Make the answer very short. 2.02. 